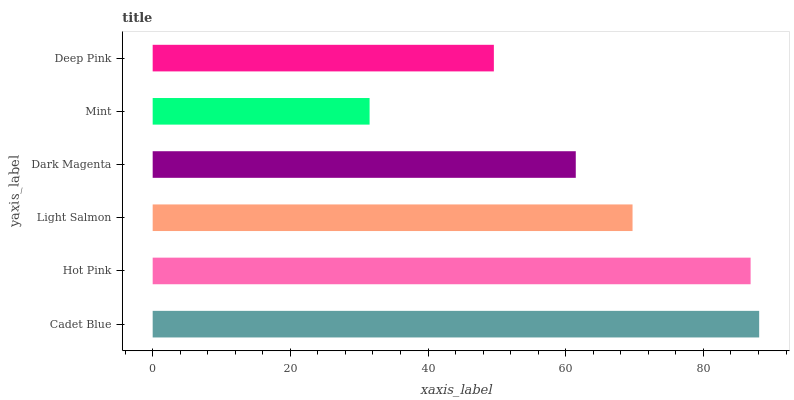Is Mint the minimum?
Answer yes or no. Yes. Is Cadet Blue the maximum?
Answer yes or no. Yes. Is Hot Pink the minimum?
Answer yes or no. No. Is Hot Pink the maximum?
Answer yes or no. No. Is Cadet Blue greater than Hot Pink?
Answer yes or no. Yes. Is Hot Pink less than Cadet Blue?
Answer yes or no. Yes. Is Hot Pink greater than Cadet Blue?
Answer yes or no. No. Is Cadet Blue less than Hot Pink?
Answer yes or no. No. Is Light Salmon the high median?
Answer yes or no. Yes. Is Dark Magenta the low median?
Answer yes or no. Yes. Is Deep Pink the high median?
Answer yes or no. No. Is Deep Pink the low median?
Answer yes or no. No. 